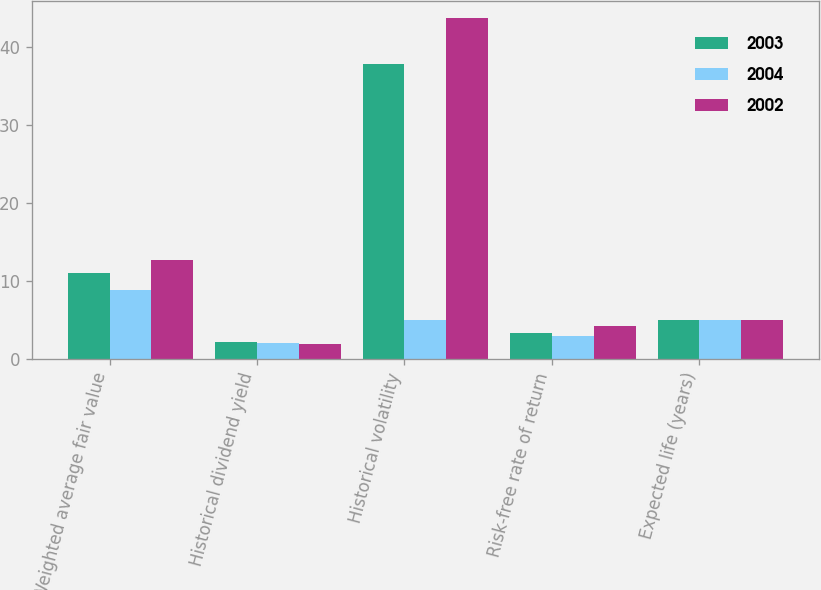Convert chart to OTSL. <chart><loc_0><loc_0><loc_500><loc_500><stacked_bar_chart><ecel><fcel>Weighted average fair value<fcel>Historical dividend yield<fcel>Historical volatility<fcel>Risk-free rate of return<fcel>Expected life (years)<nl><fcel>2003<fcel>10.97<fcel>2.1<fcel>37.9<fcel>3.3<fcel>5<nl><fcel>2004<fcel>8.82<fcel>2<fcel>5<fcel>2.9<fcel>5<nl><fcel>2002<fcel>12.64<fcel>1.9<fcel>43.8<fcel>4.2<fcel>5<nl></chart> 